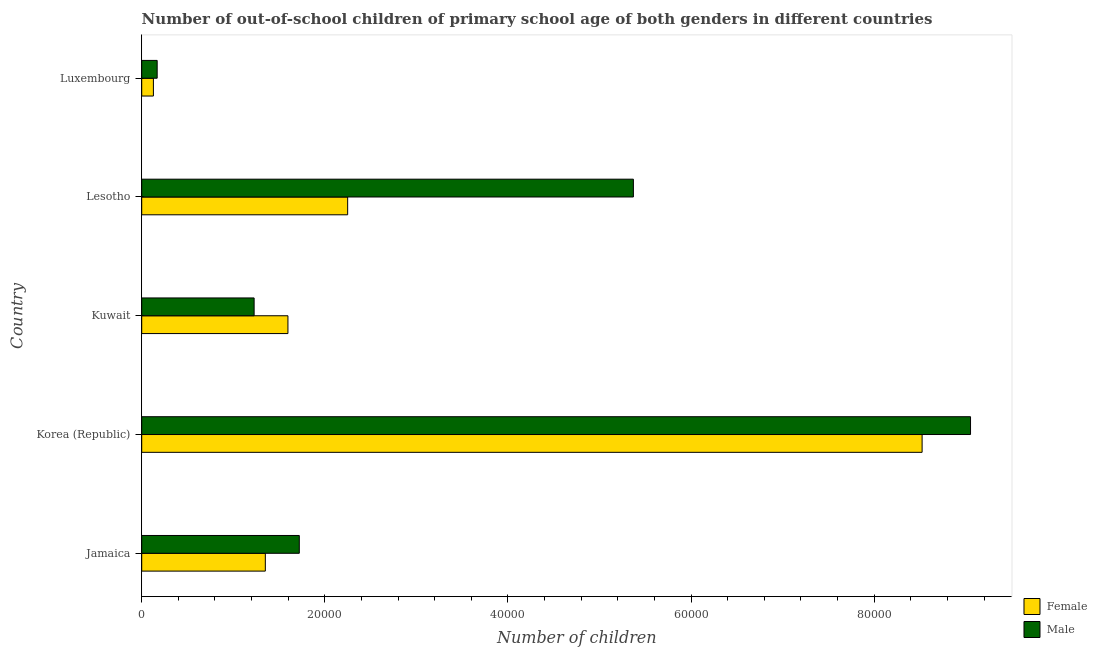How many different coloured bars are there?
Offer a very short reply. 2. How many groups of bars are there?
Ensure brevity in your answer.  5. Are the number of bars on each tick of the Y-axis equal?
Your answer should be compact. Yes. How many bars are there on the 2nd tick from the bottom?
Provide a short and direct response. 2. What is the label of the 4th group of bars from the top?
Your answer should be compact. Korea (Republic). In how many cases, is the number of bars for a given country not equal to the number of legend labels?
Give a very brief answer. 0. What is the number of male out-of-school students in Kuwait?
Your answer should be compact. 1.23e+04. Across all countries, what is the maximum number of female out-of-school students?
Provide a short and direct response. 8.52e+04. Across all countries, what is the minimum number of female out-of-school students?
Make the answer very short. 1276. In which country was the number of female out-of-school students maximum?
Your answer should be very brief. Korea (Republic). In which country was the number of male out-of-school students minimum?
Provide a short and direct response. Luxembourg. What is the total number of female out-of-school students in the graph?
Your response must be concise. 1.38e+05. What is the difference between the number of female out-of-school students in Korea (Republic) and that in Lesotho?
Your answer should be very brief. 6.27e+04. What is the difference between the number of female out-of-school students in Kuwait and the number of male out-of-school students in Korea (Republic)?
Offer a terse response. -7.46e+04. What is the average number of male out-of-school students per country?
Provide a succinct answer. 3.51e+04. What is the difference between the number of male out-of-school students and number of female out-of-school students in Lesotho?
Your answer should be compact. 3.12e+04. What is the ratio of the number of male out-of-school students in Korea (Republic) to that in Luxembourg?
Offer a very short reply. 53.66. Is the number of female out-of-school students in Korea (Republic) less than that in Lesotho?
Your answer should be compact. No. Is the difference between the number of male out-of-school students in Jamaica and Lesotho greater than the difference between the number of female out-of-school students in Jamaica and Lesotho?
Your response must be concise. No. What is the difference between the highest and the second highest number of male out-of-school students?
Your response must be concise. 3.68e+04. What is the difference between the highest and the lowest number of female out-of-school students?
Offer a very short reply. 8.40e+04. What does the 1st bar from the top in Luxembourg represents?
Your response must be concise. Male. Are all the bars in the graph horizontal?
Offer a terse response. Yes. How many countries are there in the graph?
Offer a very short reply. 5. Are the values on the major ticks of X-axis written in scientific E-notation?
Your answer should be very brief. No. Does the graph contain any zero values?
Give a very brief answer. No. What is the title of the graph?
Ensure brevity in your answer.  Number of out-of-school children of primary school age of both genders in different countries. Does "National Tourists" appear as one of the legend labels in the graph?
Give a very brief answer. No. What is the label or title of the X-axis?
Offer a terse response. Number of children. What is the Number of children of Female in Jamaica?
Keep it short and to the point. 1.35e+04. What is the Number of children in Male in Jamaica?
Keep it short and to the point. 1.72e+04. What is the Number of children in Female in Korea (Republic)?
Offer a very short reply. 8.52e+04. What is the Number of children of Male in Korea (Republic)?
Provide a short and direct response. 9.05e+04. What is the Number of children in Female in Kuwait?
Give a very brief answer. 1.60e+04. What is the Number of children of Male in Kuwait?
Offer a very short reply. 1.23e+04. What is the Number of children in Female in Lesotho?
Keep it short and to the point. 2.25e+04. What is the Number of children in Male in Lesotho?
Make the answer very short. 5.37e+04. What is the Number of children of Female in Luxembourg?
Provide a succinct answer. 1276. What is the Number of children in Male in Luxembourg?
Keep it short and to the point. 1687. Across all countries, what is the maximum Number of children in Female?
Offer a terse response. 8.52e+04. Across all countries, what is the maximum Number of children of Male?
Offer a terse response. 9.05e+04. Across all countries, what is the minimum Number of children of Female?
Your response must be concise. 1276. Across all countries, what is the minimum Number of children of Male?
Your answer should be compact. 1687. What is the total Number of children of Female in the graph?
Provide a short and direct response. 1.38e+05. What is the total Number of children of Male in the graph?
Provide a succinct answer. 1.75e+05. What is the difference between the Number of children in Female in Jamaica and that in Korea (Republic)?
Provide a short and direct response. -7.17e+04. What is the difference between the Number of children in Male in Jamaica and that in Korea (Republic)?
Offer a very short reply. -7.33e+04. What is the difference between the Number of children in Female in Jamaica and that in Kuwait?
Provide a succinct answer. -2469. What is the difference between the Number of children of Male in Jamaica and that in Kuwait?
Provide a succinct answer. 4935. What is the difference between the Number of children of Female in Jamaica and that in Lesotho?
Provide a short and direct response. -8992. What is the difference between the Number of children in Male in Jamaica and that in Lesotho?
Your answer should be compact. -3.65e+04. What is the difference between the Number of children of Female in Jamaica and that in Luxembourg?
Make the answer very short. 1.22e+04. What is the difference between the Number of children of Male in Jamaica and that in Luxembourg?
Give a very brief answer. 1.55e+04. What is the difference between the Number of children in Female in Korea (Republic) and that in Kuwait?
Ensure brevity in your answer.  6.93e+04. What is the difference between the Number of children in Male in Korea (Republic) and that in Kuwait?
Your response must be concise. 7.83e+04. What is the difference between the Number of children of Female in Korea (Republic) and that in Lesotho?
Offer a very short reply. 6.27e+04. What is the difference between the Number of children in Male in Korea (Republic) and that in Lesotho?
Your response must be concise. 3.68e+04. What is the difference between the Number of children in Female in Korea (Republic) and that in Luxembourg?
Provide a succinct answer. 8.40e+04. What is the difference between the Number of children of Male in Korea (Republic) and that in Luxembourg?
Offer a terse response. 8.88e+04. What is the difference between the Number of children of Female in Kuwait and that in Lesotho?
Ensure brevity in your answer.  -6523. What is the difference between the Number of children in Male in Kuwait and that in Lesotho?
Keep it short and to the point. -4.14e+04. What is the difference between the Number of children in Female in Kuwait and that in Luxembourg?
Give a very brief answer. 1.47e+04. What is the difference between the Number of children of Male in Kuwait and that in Luxembourg?
Ensure brevity in your answer.  1.06e+04. What is the difference between the Number of children of Female in Lesotho and that in Luxembourg?
Give a very brief answer. 2.12e+04. What is the difference between the Number of children of Male in Lesotho and that in Luxembourg?
Keep it short and to the point. 5.20e+04. What is the difference between the Number of children of Female in Jamaica and the Number of children of Male in Korea (Republic)?
Give a very brief answer. -7.70e+04. What is the difference between the Number of children in Female in Jamaica and the Number of children in Male in Kuwait?
Offer a terse response. 1224. What is the difference between the Number of children in Female in Jamaica and the Number of children in Male in Lesotho?
Give a very brief answer. -4.02e+04. What is the difference between the Number of children in Female in Jamaica and the Number of children in Male in Luxembourg?
Offer a very short reply. 1.18e+04. What is the difference between the Number of children of Female in Korea (Republic) and the Number of children of Male in Kuwait?
Keep it short and to the point. 7.30e+04. What is the difference between the Number of children of Female in Korea (Republic) and the Number of children of Male in Lesotho?
Make the answer very short. 3.15e+04. What is the difference between the Number of children of Female in Korea (Republic) and the Number of children of Male in Luxembourg?
Give a very brief answer. 8.36e+04. What is the difference between the Number of children of Female in Kuwait and the Number of children of Male in Lesotho?
Ensure brevity in your answer.  -3.77e+04. What is the difference between the Number of children of Female in Kuwait and the Number of children of Male in Luxembourg?
Provide a succinct answer. 1.43e+04. What is the difference between the Number of children of Female in Lesotho and the Number of children of Male in Luxembourg?
Give a very brief answer. 2.08e+04. What is the average Number of children of Female per country?
Ensure brevity in your answer.  2.77e+04. What is the average Number of children of Male per country?
Offer a very short reply. 3.51e+04. What is the difference between the Number of children of Female and Number of children of Male in Jamaica?
Your answer should be compact. -3711. What is the difference between the Number of children of Female and Number of children of Male in Korea (Republic)?
Give a very brief answer. -5290. What is the difference between the Number of children of Female and Number of children of Male in Kuwait?
Your response must be concise. 3693. What is the difference between the Number of children of Female and Number of children of Male in Lesotho?
Give a very brief answer. -3.12e+04. What is the difference between the Number of children of Female and Number of children of Male in Luxembourg?
Make the answer very short. -411. What is the ratio of the Number of children in Female in Jamaica to that in Korea (Republic)?
Provide a succinct answer. 0.16. What is the ratio of the Number of children in Male in Jamaica to that in Korea (Republic)?
Give a very brief answer. 0.19. What is the ratio of the Number of children of Female in Jamaica to that in Kuwait?
Keep it short and to the point. 0.85. What is the ratio of the Number of children of Male in Jamaica to that in Kuwait?
Your response must be concise. 1.4. What is the ratio of the Number of children in Female in Jamaica to that in Lesotho?
Ensure brevity in your answer.  0.6. What is the ratio of the Number of children of Male in Jamaica to that in Lesotho?
Offer a terse response. 0.32. What is the ratio of the Number of children of Female in Jamaica to that in Luxembourg?
Your response must be concise. 10.58. What is the ratio of the Number of children of Male in Jamaica to that in Luxembourg?
Offer a terse response. 10.2. What is the ratio of the Number of children of Female in Korea (Republic) to that in Kuwait?
Offer a terse response. 5.34. What is the ratio of the Number of children in Male in Korea (Republic) to that in Kuwait?
Your answer should be compact. 7.37. What is the ratio of the Number of children of Female in Korea (Republic) to that in Lesotho?
Your answer should be compact. 3.79. What is the ratio of the Number of children of Male in Korea (Republic) to that in Lesotho?
Ensure brevity in your answer.  1.69. What is the ratio of the Number of children of Female in Korea (Republic) to that in Luxembourg?
Offer a very short reply. 66.8. What is the ratio of the Number of children of Male in Korea (Republic) to that in Luxembourg?
Give a very brief answer. 53.66. What is the ratio of the Number of children in Female in Kuwait to that in Lesotho?
Offer a terse response. 0.71. What is the ratio of the Number of children in Male in Kuwait to that in Lesotho?
Offer a very short reply. 0.23. What is the ratio of the Number of children in Female in Kuwait to that in Luxembourg?
Make the answer very short. 12.52. What is the ratio of the Number of children in Male in Kuwait to that in Luxembourg?
Make the answer very short. 7.28. What is the ratio of the Number of children in Female in Lesotho to that in Luxembourg?
Your answer should be compact. 17.63. What is the ratio of the Number of children of Male in Lesotho to that in Luxembourg?
Keep it short and to the point. 31.83. What is the difference between the highest and the second highest Number of children in Female?
Your answer should be very brief. 6.27e+04. What is the difference between the highest and the second highest Number of children in Male?
Give a very brief answer. 3.68e+04. What is the difference between the highest and the lowest Number of children in Female?
Your answer should be very brief. 8.40e+04. What is the difference between the highest and the lowest Number of children in Male?
Your answer should be compact. 8.88e+04. 